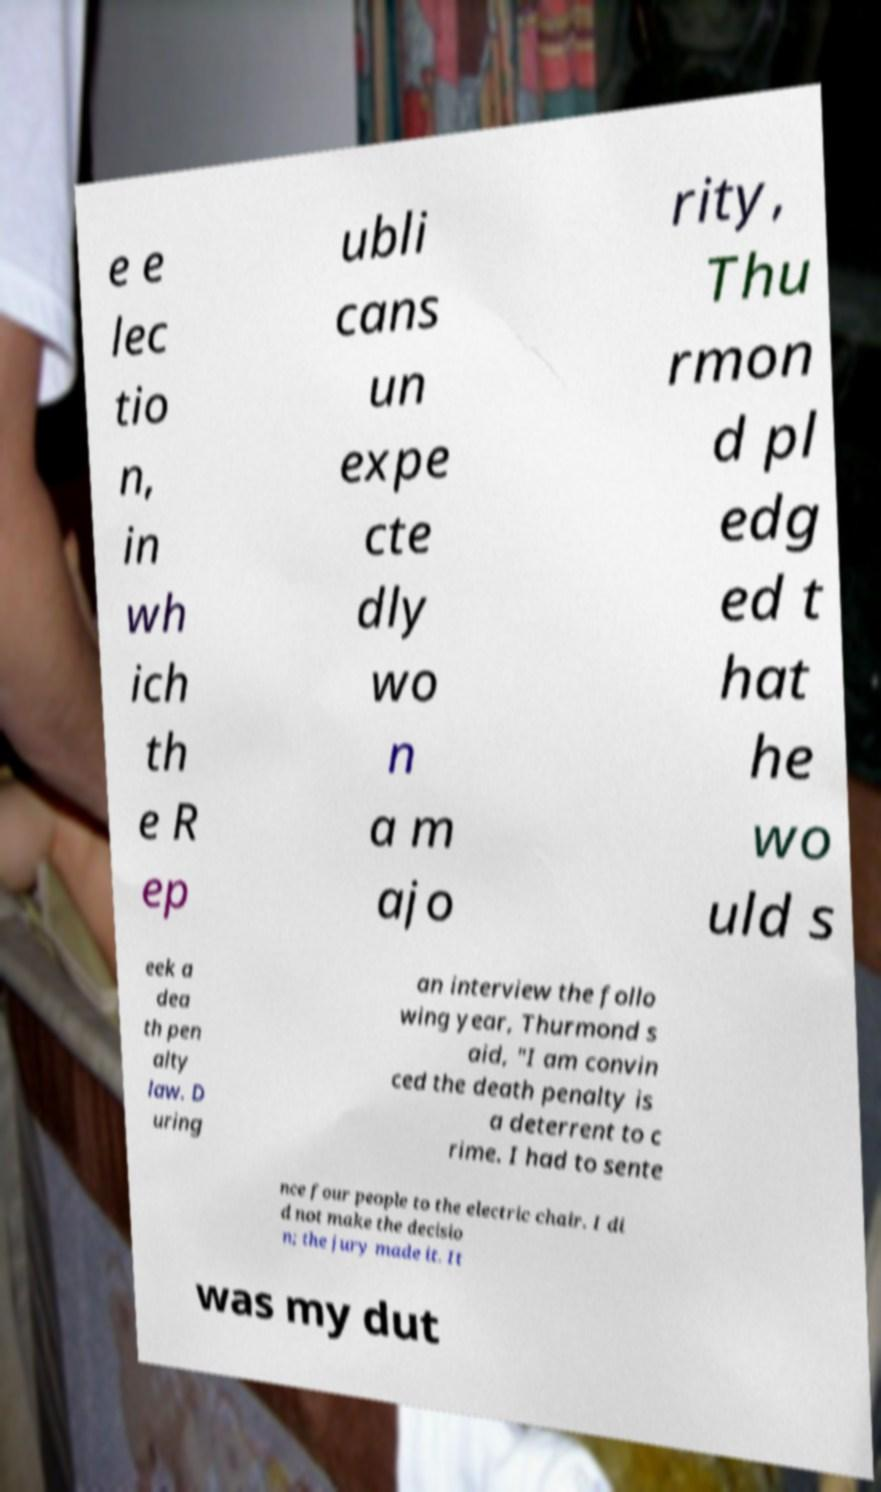For documentation purposes, I need the text within this image transcribed. Could you provide that? e e lec tio n, in wh ich th e R ep ubli cans un expe cte dly wo n a m ajo rity, Thu rmon d pl edg ed t hat he wo uld s eek a dea th pen alty law. D uring an interview the follo wing year, Thurmond s aid, "I am convin ced the death penalty is a deterrent to c rime. I had to sente nce four people to the electric chair. I di d not make the decisio n; the jury made it. It was my dut 